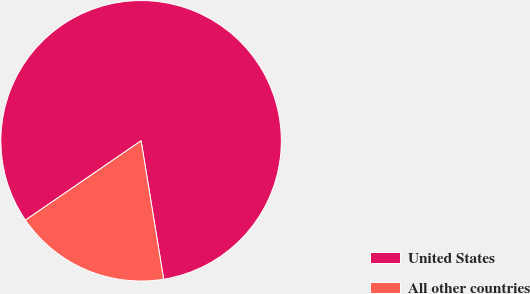Convert chart to OTSL. <chart><loc_0><loc_0><loc_500><loc_500><pie_chart><fcel>United States<fcel>All other countries<nl><fcel>82.0%<fcel>18.0%<nl></chart> 